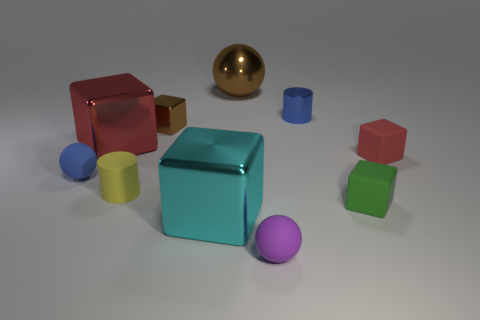What is the material of the purple ball that is the same size as the yellow rubber object?
Offer a terse response. Rubber. The blue object that is the same material as the purple thing is what size?
Offer a terse response. Small. There is a large red object that is the same shape as the small brown object; what is it made of?
Offer a terse response. Metal. There is a red cube right of the tiny brown cube; is it the same size as the shiny block that is on the left side of the tiny brown block?
Your answer should be compact. No. What material is the cylinder in front of the tiny matte ball that is to the left of the big metallic ball?
Keep it short and to the point. Rubber. What is the shape of the small yellow object that is the same material as the blue sphere?
Make the answer very short. Cylinder. Do the small green thing and the tiny brown shiny thing have the same shape?
Make the answer very short. Yes. Is there a big thing to the left of the red thing left of the tiny yellow matte cylinder?
Ensure brevity in your answer.  No. Does the small cylinder that is behind the brown shiny block have the same material as the small ball that is in front of the blue matte sphere?
Offer a very short reply. No. There is a rubber object to the left of the red object left of the large cyan shiny thing; how big is it?
Offer a very short reply. Small. 